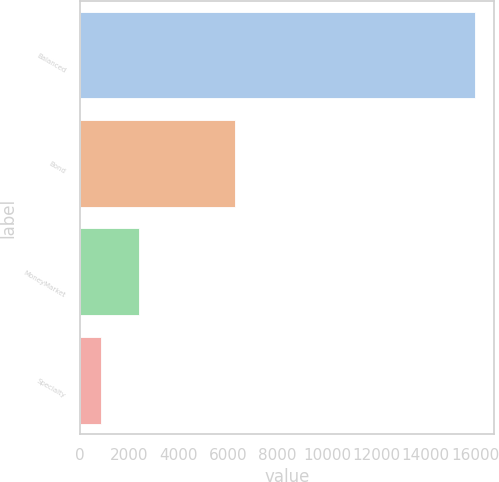<chart> <loc_0><loc_0><loc_500><loc_500><bar_chart><fcel>Balanced<fcel>Bond<fcel>MoneyMarket<fcel>Specialty<nl><fcel>15977<fcel>6284<fcel>2380.7<fcel>870<nl></chart> 